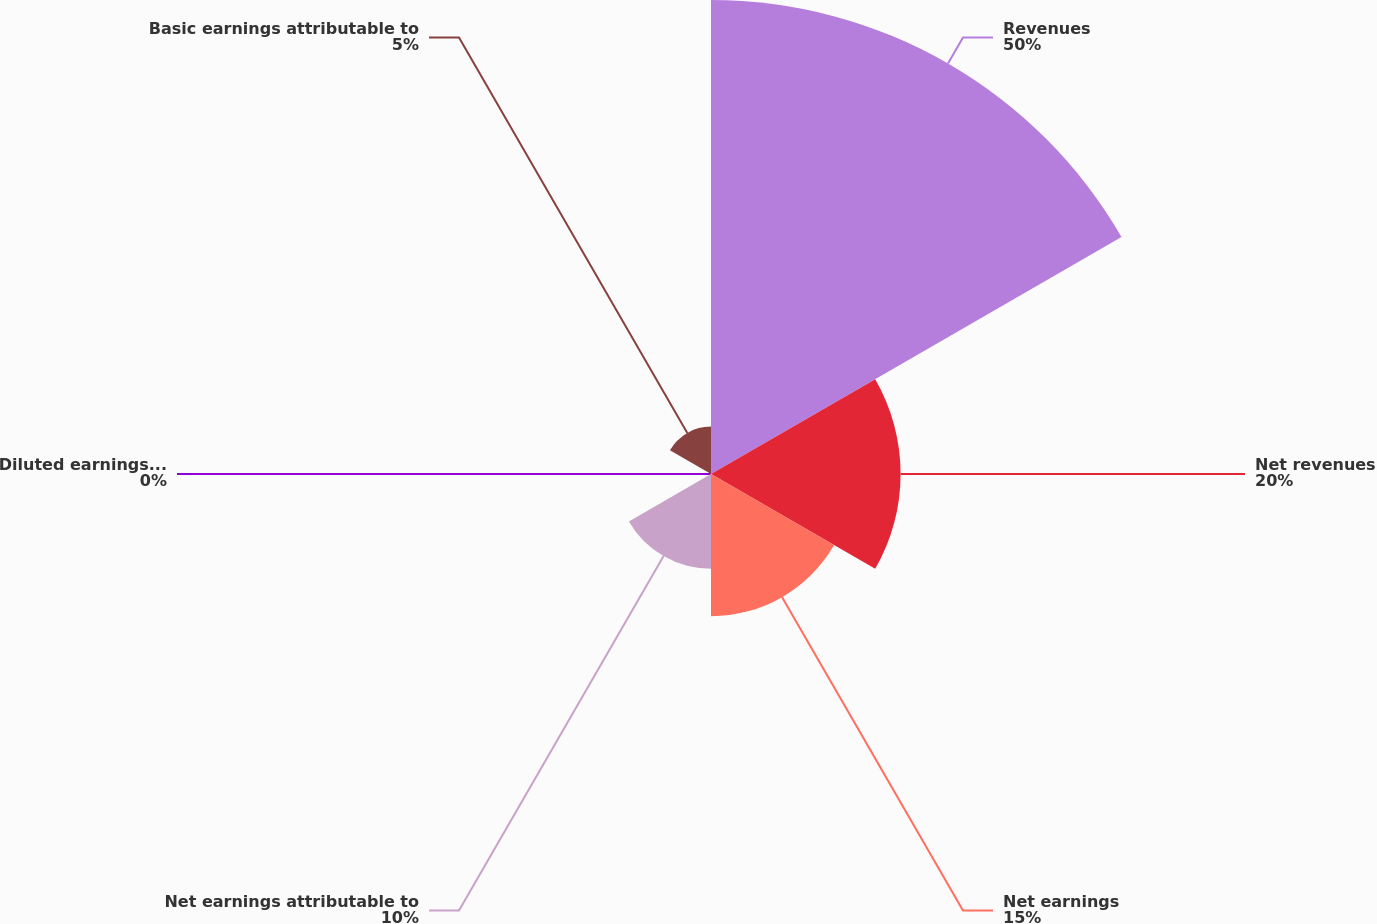Convert chart to OTSL. <chart><loc_0><loc_0><loc_500><loc_500><pie_chart><fcel>Revenues<fcel>Net revenues<fcel>Net earnings<fcel>Net earnings attributable to<fcel>Diluted earnings attributable<fcel>Basic earnings attributable to<nl><fcel>50.0%<fcel>20.0%<fcel>15.0%<fcel>10.0%<fcel>0.0%<fcel>5.0%<nl></chart> 